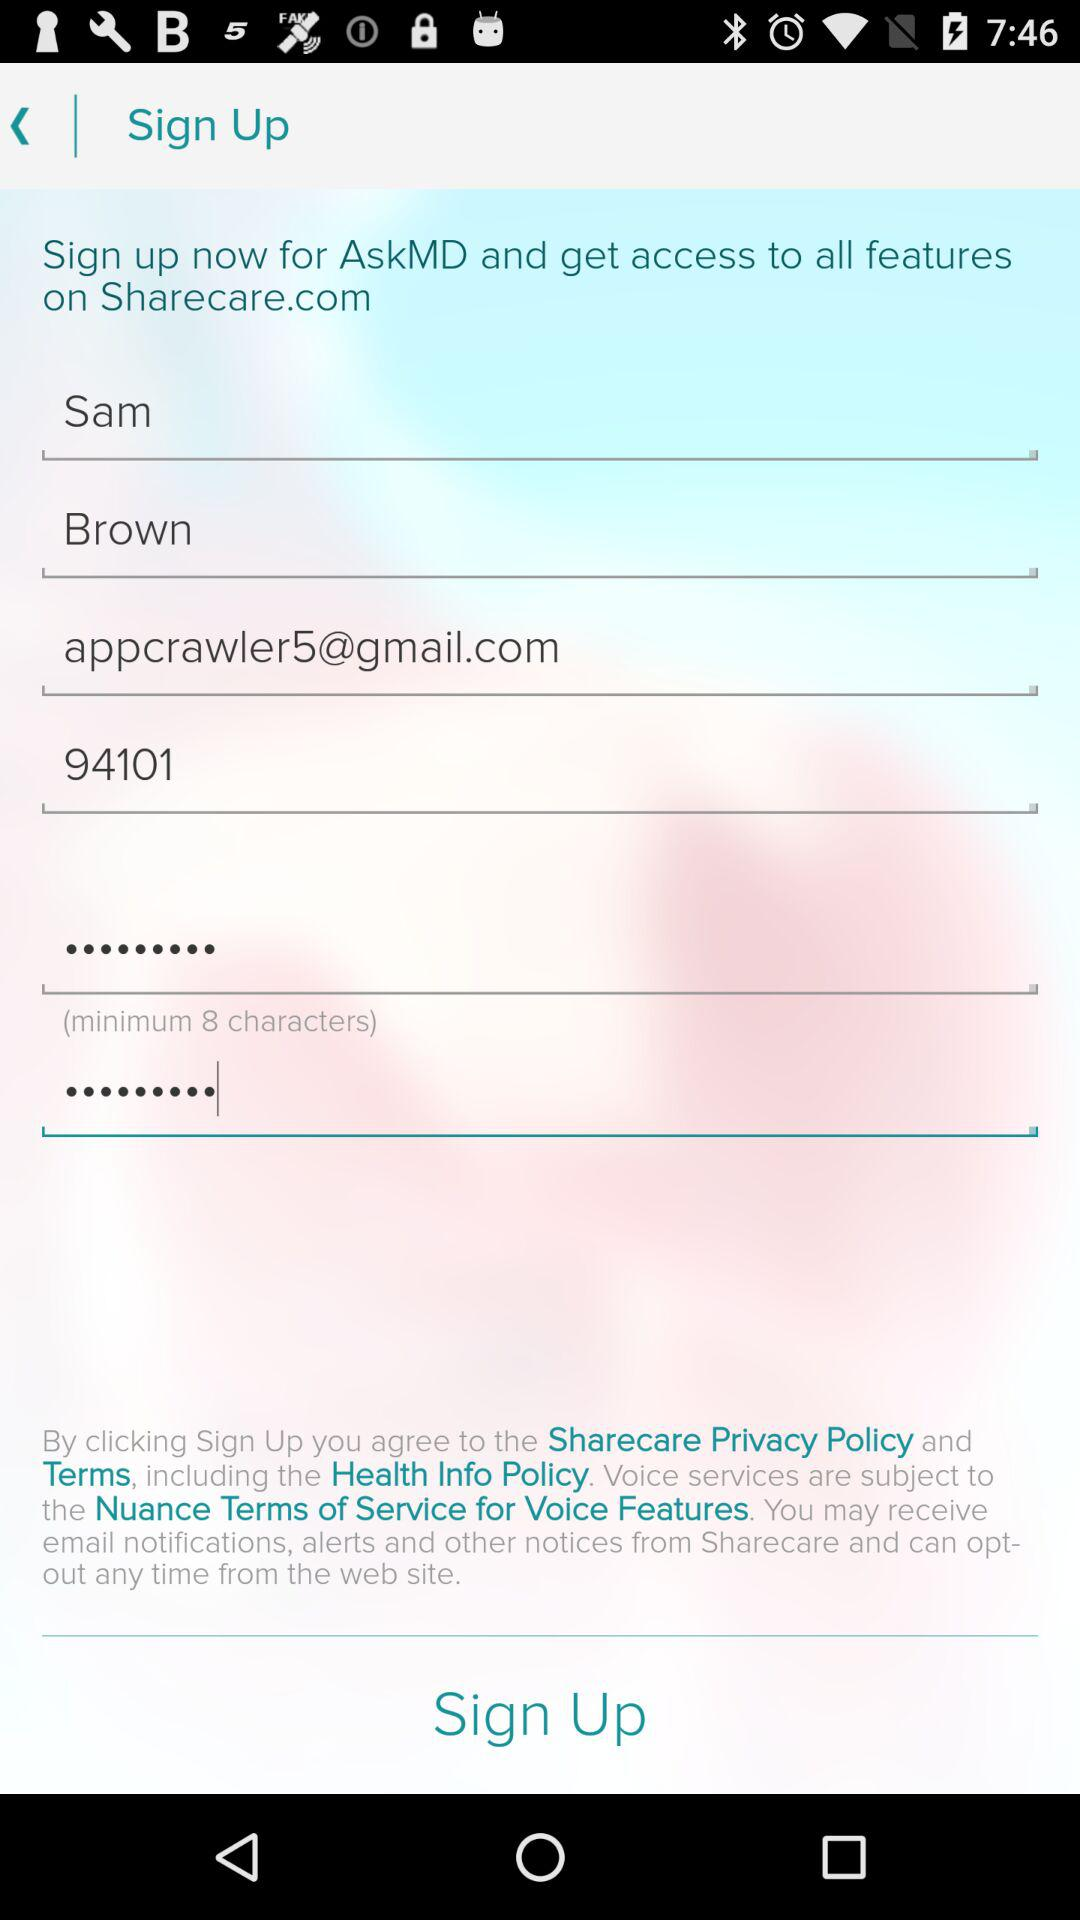What is the email address? The email address is appcrawler5@gmail.com. 